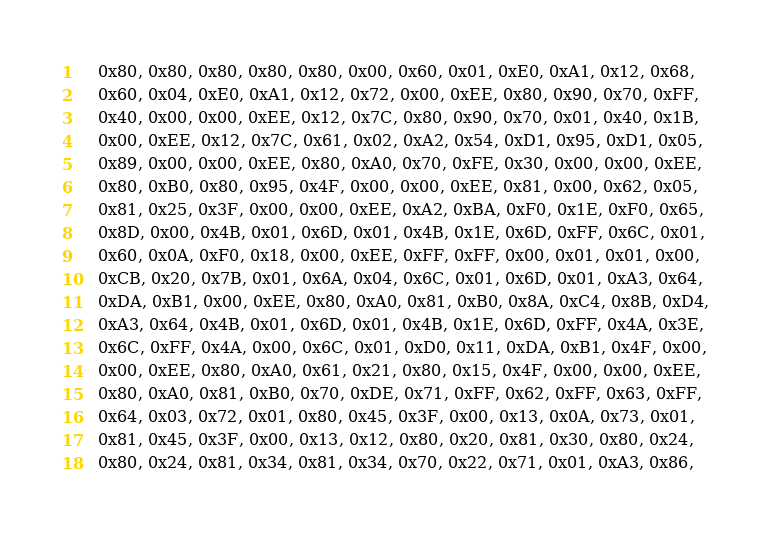Convert code to text. <code><loc_0><loc_0><loc_500><loc_500><_C_>	0x80, 0x80, 0x80, 0x80, 0x80, 0x00, 0x60, 0x01, 0xE0, 0xA1, 0x12, 0x68,
	0x60, 0x04, 0xE0, 0xA1, 0x12, 0x72, 0x00, 0xEE, 0x80, 0x90, 0x70, 0xFF,
	0x40, 0x00, 0x00, 0xEE, 0x12, 0x7C, 0x80, 0x90, 0x70, 0x01, 0x40, 0x1B,
	0x00, 0xEE, 0x12, 0x7C, 0x61, 0x02, 0xA2, 0x54, 0xD1, 0x95, 0xD1, 0x05,
	0x89, 0x00, 0x00, 0xEE, 0x80, 0xA0, 0x70, 0xFE, 0x30, 0x00, 0x00, 0xEE,
	0x80, 0xB0, 0x80, 0x95, 0x4F, 0x00, 0x00, 0xEE, 0x81, 0x00, 0x62, 0x05,
	0x81, 0x25, 0x3F, 0x00, 0x00, 0xEE, 0xA2, 0xBA, 0xF0, 0x1E, 0xF0, 0x65,
	0x8D, 0x00, 0x4B, 0x01, 0x6D, 0x01, 0x4B, 0x1E, 0x6D, 0xFF, 0x6C, 0x01,
	0x60, 0x0A, 0xF0, 0x18, 0x00, 0xEE, 0xFF, 0xFF, 0x00, 0x01, 0x01, 0x00,
	0xCB, 0x20, 0x7B, 0x01, 0x6A, 0x04, 0x6C, 0x01, 0x6D, 0x01, 0xA3, 0x64,
	0xDA, 0xB1, 0x00, 0xEE, 0x80, 0xA0, 0x81, 0xB0, 0x8A, 0xC4, 0x8B, 0xD4,
	0xA3, 0x64, 0x4B, 0x01, 0x6D, 0x01, 0x4B, 0x1E, 0x6D, 0xFF, 0x4A, 0x3E,
	0x6C, 0xFF, 0x4A, 0x00, 0x6C, 0x01, 0xD0, 0x11, 0xDA, 0xB1, 0x4F, 0x00,
	0x00, 0xEE, 0x80, 0xA0, 0x61, 0x21, 0x80, 0x15, 0x4F, 0x00, 0x00, 0xEE,
	0x80, 0xA0, 0x81, 0xB0, 0x70, 0xDE, 0x71, 0xFF, 0x62, 0xFF, 0x63, 0xFF,
	0x64, 0x03, 0x72, 0x01, 0x80, 0x45, 0x3F, 0x00, 0x13, 0x0A, 0x73, 0x01,
	0x81, 0x45, 0x3F, 0x00, 0x13, 0x12, 0x80, 0x20, 0x81, 0x30, 0x80, 0x24,
	0x80, 0x24, 0x81, 0x34, 0x81, 0x34, 0x70, 0x22, 0x71, 0x01, 0xA3, 0x86,</code> 